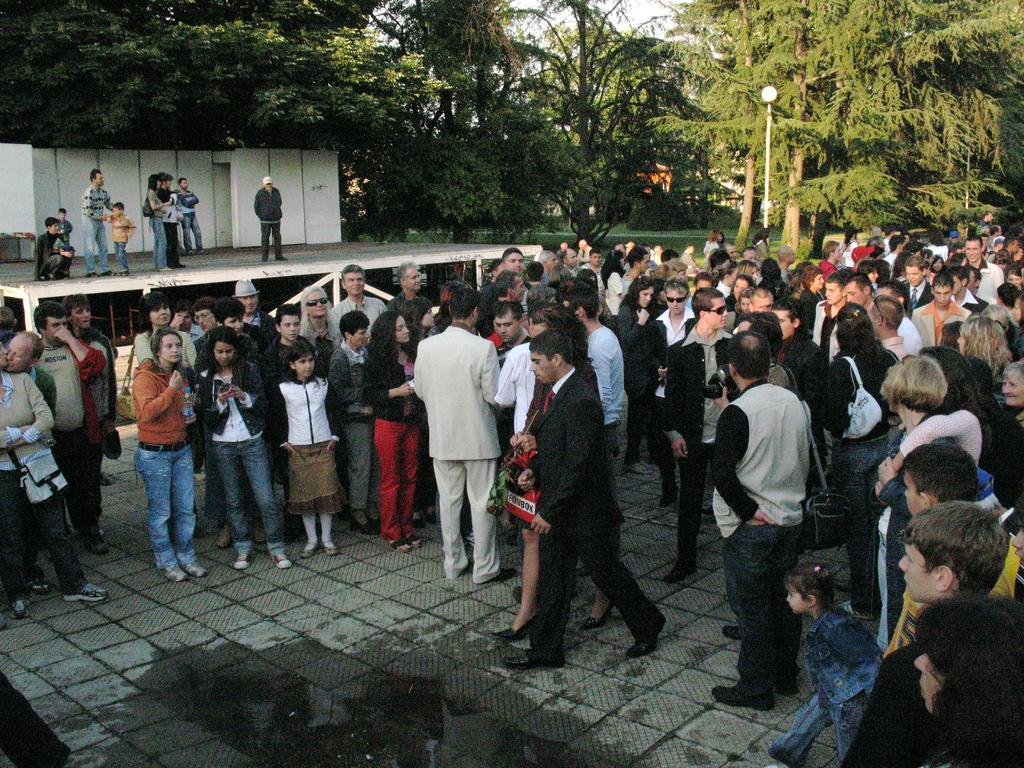What is the main subject of the image? The main subject of the image is a group of persons standing in the center. Where are the persons standing? The group of persons is standing on the floor. What can be seen in the background of the image? There are persons, trees, a street light, grass, and the sky visible in the background. What type of basin is visible in the image? There is no basin present in the image. How does the afterthought contribute to the image? The concept of an "afterthought" is not applicable to the image, as it refers to a thought that comes later and is not directly related to the image's content. 